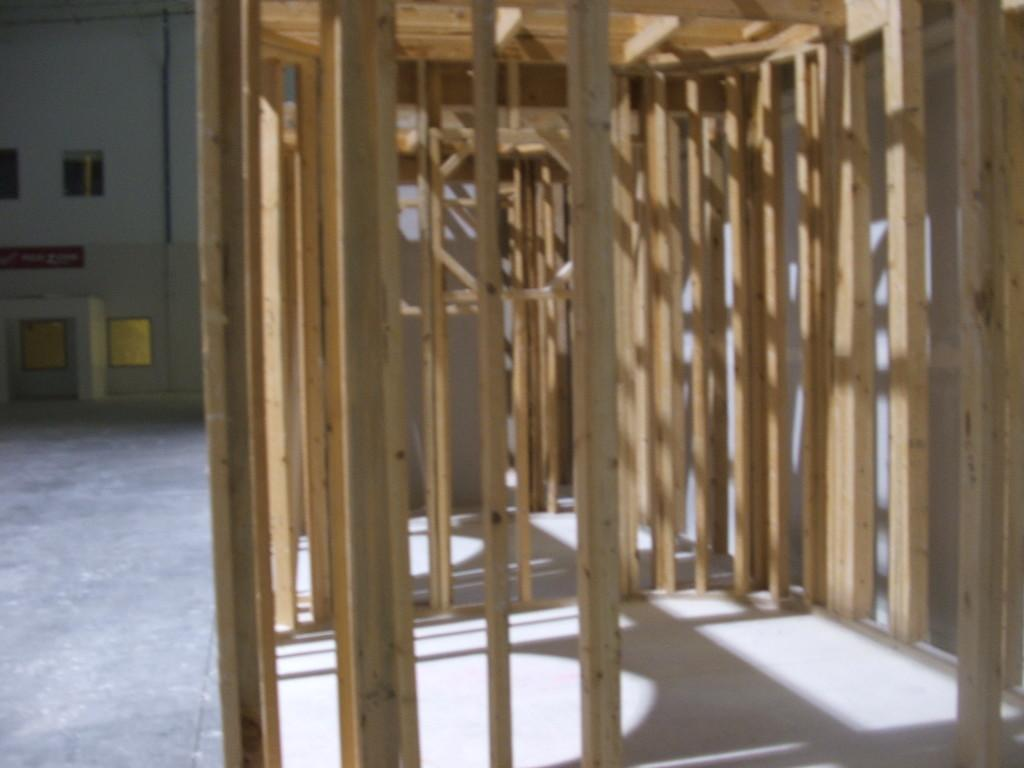What is located in the center of the image? There is a wooden cage in the center of the image. What can be seen in the background of the image? There is a building in the background of the image. What type of feather can be seen on the lip of the wooden cage in the image? There is no feather or lip present on the wooden cage in the image. 